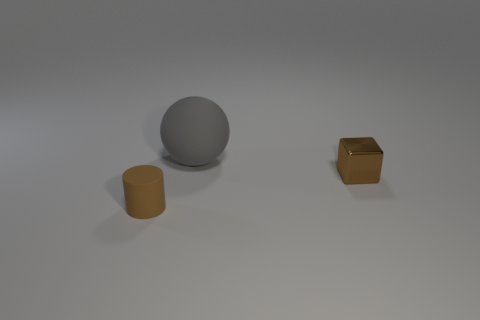How many other objects are there of the same shape as the metal thing?
Offer a very short reply. 0. There is a tiny metallic object; does it have the same shape as the tiny brown object to the left of the small brown metallic block?
Give a very brief answer. No. There is a rubber cylinder; how many objects are behind it?
Your response must be concise. 2. Is there any other thing that has the same material as the large gray sphere?
Your response must be concise. Yes. There is a tiny brown thing that is in front of the metallic object; is its shape the same as the large gray object?
Keep it short and to the point. No. There is a tiny thing to the right of the rubber cylinder; what is its color?
Keep it short and to the point. Brown. There is a big gray object that is the same material as the brown cylinder; what is its shape?
Your answer should be compact. Sphere. Is there anything else that has the same color as the big thing?
Ensure brevity in your answer.  No. Is the number of small rubber things that are behind the gray matte ball greater than the number of matte spheres that are on the right side of the small brown matte cylinder?
Your answer should be very brief. No. What number of other yellow matte cylinders are the same size as the rubber cylinder?
Offer a very short reply. 0. 